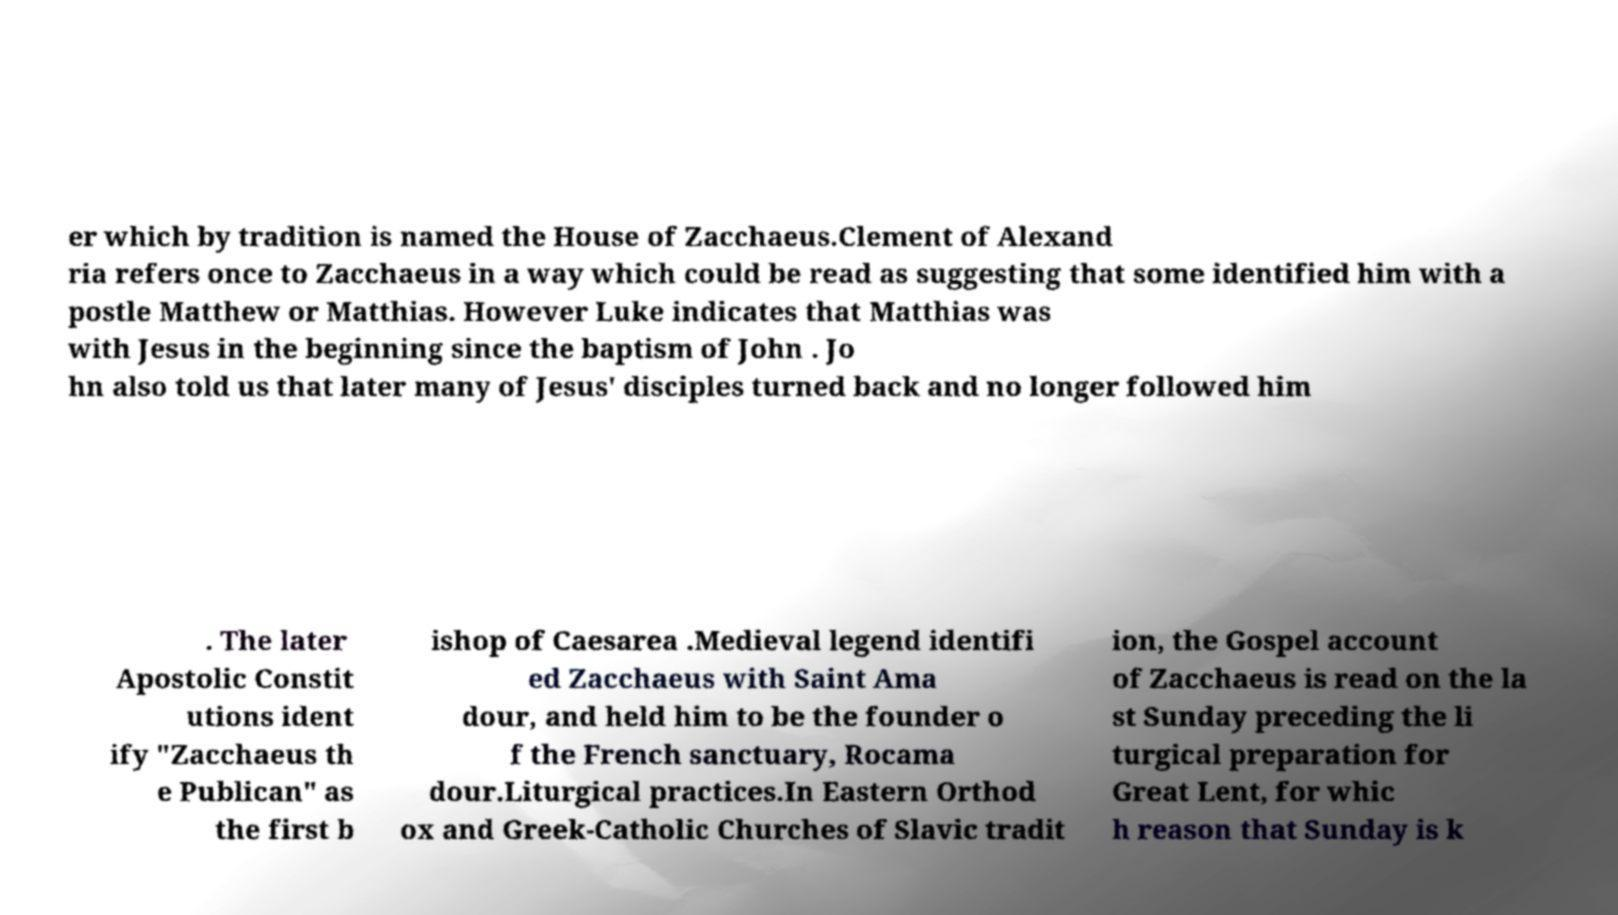There's text embedded in this image that I need extracted. Can you transcribe it verbatim? er which by tradition is named the House of Zacchaeus.Clement of Alexand ria refers once to Zacchaeus in a way which could be read as suggesting that some identified him with a postle Matthew or Matthias. However Luke indicates that Matthias was with Jesus in the beginning since the baptism of John . Jo hn also told us that later many of Jesus' disciples turned back and no longer followed him . The later Apostolic Constit utions ident ify "Zacchaeus th e Publican" as the first b ishop of Caesarea .Medieval legend identifi ed Zacchaeus with Saint Ama dour, and held him to be the founder o f the French sanctuary, Rocama dour.Liturgical practices.In Eastern Orthod ox and Greek-Catholic Churches of Slavic tradit ion, the Gospel account of Zacchaeus is read on the la st Sunday preceding the li turgical preparation for Great Lent, for whic h reason that Sunday is k 